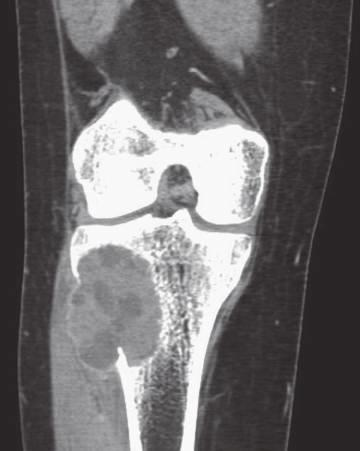what is the soft tissue component delineated by?
Answer the question using a single word or phrase. A thin rim of reactive subperiosteal bone 